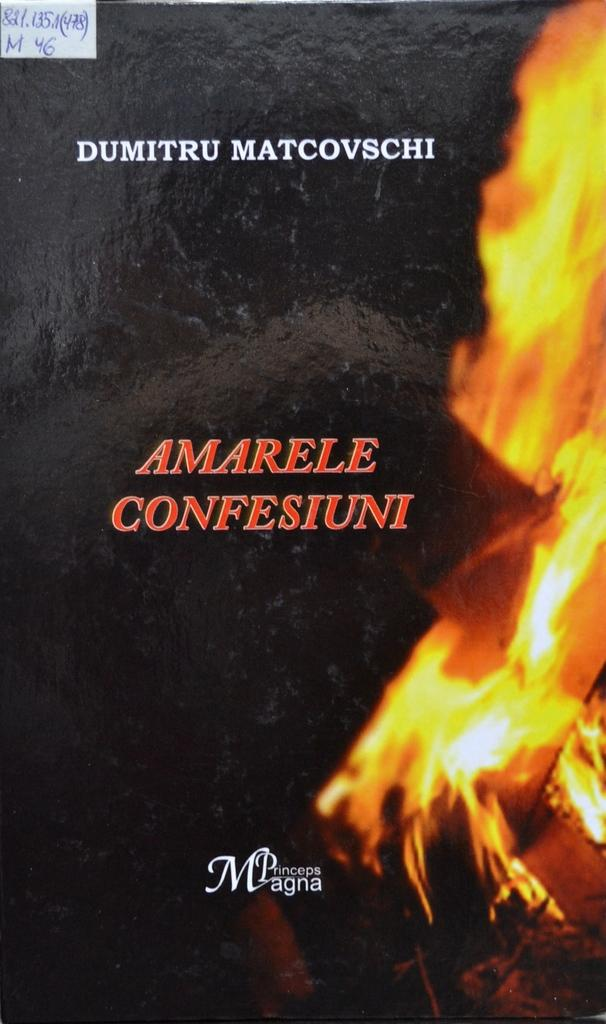Provide a one-sentence caption for the provided image. Cover that says "Amarele Confesiuni" in red and the word Princeps Magna on the bottom. 